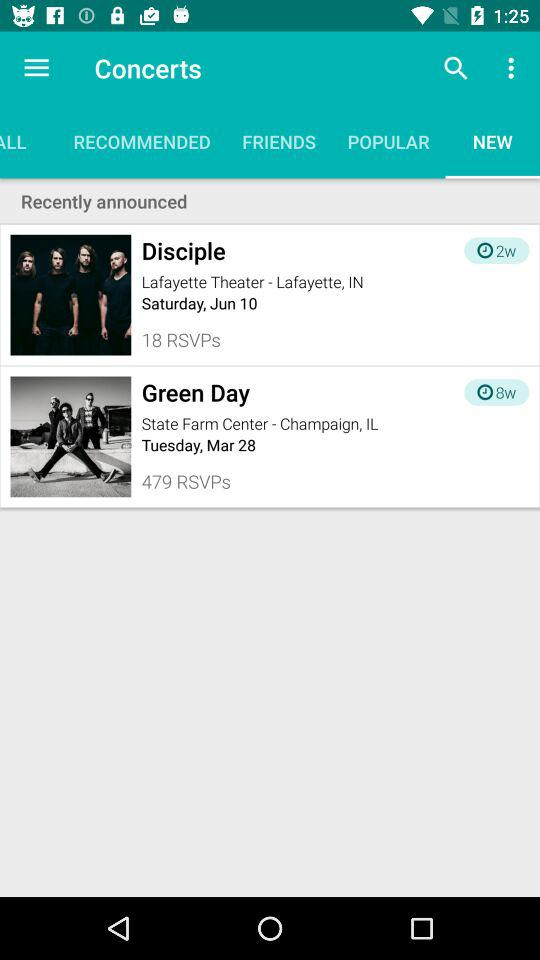Which band's concert is scheduled for March 28th? The name of the band whose concert is scheduled for March 28th is "Green Day". 